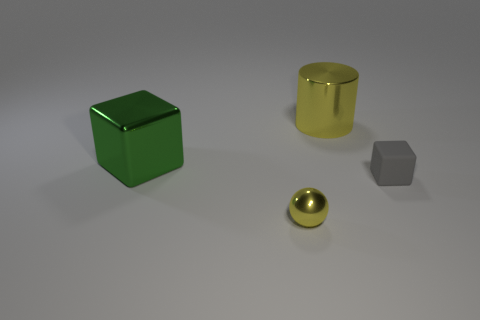Add 2 cylinders. How many objects exist? 6 Subtract all cylinders. How many objects are left? 3 Subtract all tiny cyan spheres. Subtract all green metallic blocks. How many objects are left? 3 Add 4 tiny gray matte things. How many tiny gray matte things are left? 5 Add 4 yellow things. How many yellow things exist? 6 Subtract 0 purple blocks. How many objects are left? 4 